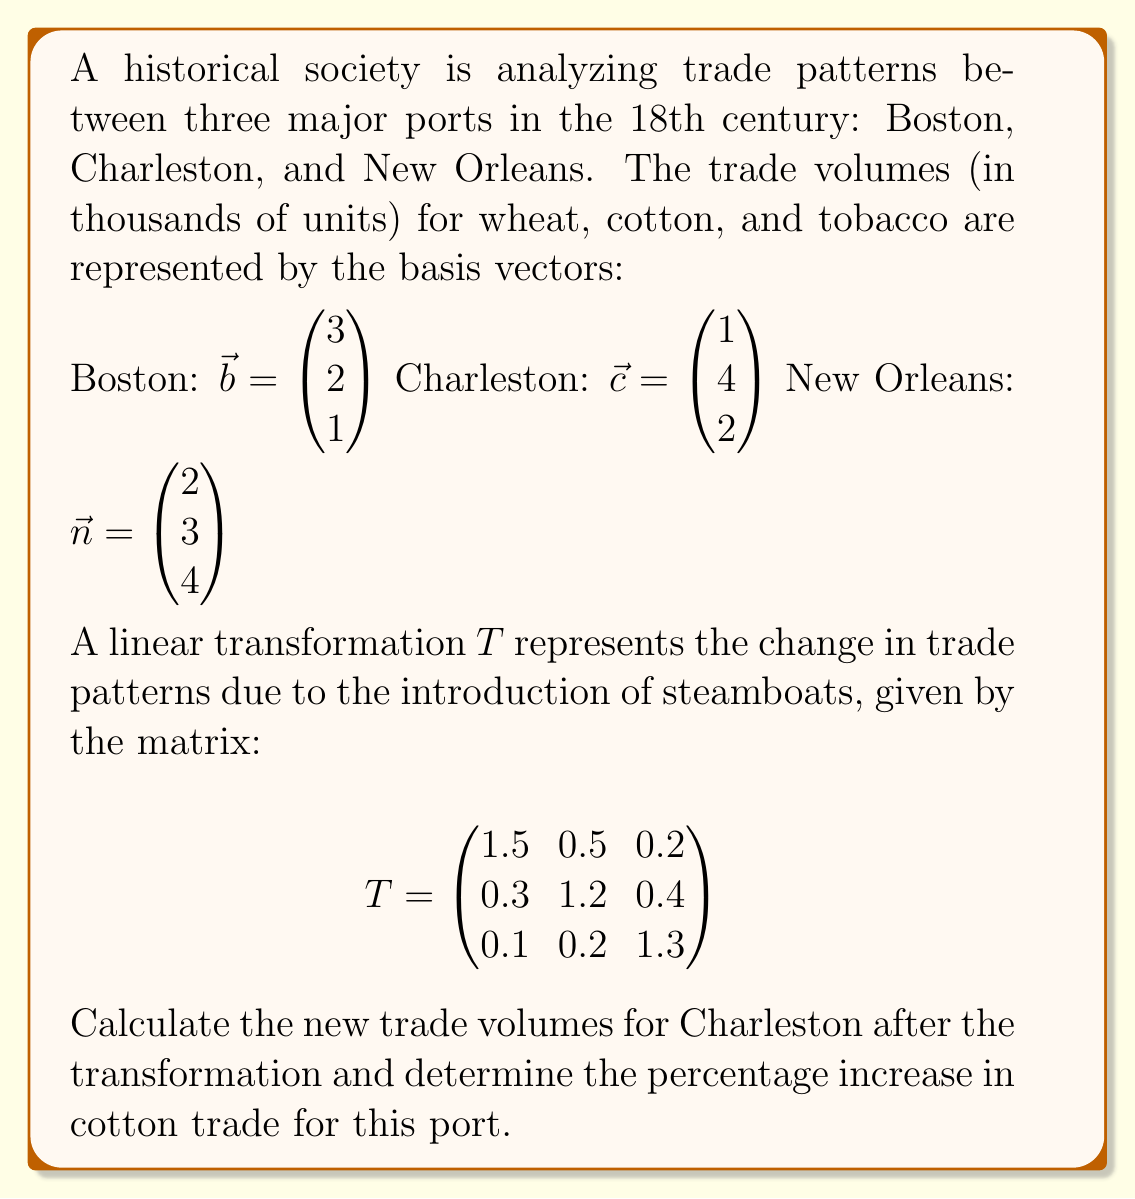Show me your answer to this math problem. To solve this problem, we need to follow these steps:

1) Apply the linear transformation $T$ to Charleston's basis vector $\vec{c}$:

   $T\vec{c} = \begin{pmatrix}
   1.5 & 0.5 & 0.2 \\
   0.3 & 1.2 & 0.4 \\
   0.1 & 0.2 & 1.3
   \end{pmatrix} \begin{pmatrix} 1 \\ 4 \\ 2 \end{pmatrix}$

2) Multiply the matrix by the vector:

   $T\vec{c} = \begin{pmatrix}
   (1.5)(1) + (0.5)(4) + (0.2)(2) \\
   (0.3)(1) + (1.2)(4) + (0.4)(2) \\
   (0.1)(1) + (0.2)(4) + (1.3)(2)
   \end{pmatrix}$

3) Calculate each component:

   $T\vec{c} = \begin{pmatrix}
   1.5 + 2.0 + 0.4 \\
   0.3 + 4.8 + 0.8 \\
   0.1 + 0.8 + 2.6
   \end{pmatrix} = \begin{pmatrix}
   3.9 \\
   5.9 \\
   3.5
   \end{pmatrix}$

4) The original cotton trade for Charleston was 4 thousand units (the second component of $\vec{c}$).
   The new cotton trade is 5.9 thousand units (the second component of $T\vec{c}$).

5) Calculate the percentage increase:

   Percentage increase = $\frac{\text{Increase}}{\text{Original}} \times 100\%$
                       = $\frac{5.9 - 4.0}{4.0} \times 100\%$
                       = $\frac{1.9}{4.0} \times 100\%$
                       = $0.475 \times 100\%$
                       = $47.5\%$

Therefore, the cotton trade for Charleston increased by 47.5% after the introduction of steamboats.
Answer: The new trade volumes for Charleston after the transformation are $\begin{pmatrix} 3.9 \\ 5.9 \\ 3.5 \end{pmatrix}$ thousand units, and the percentage increase in cotton trade for Charleston is 47.5%. 